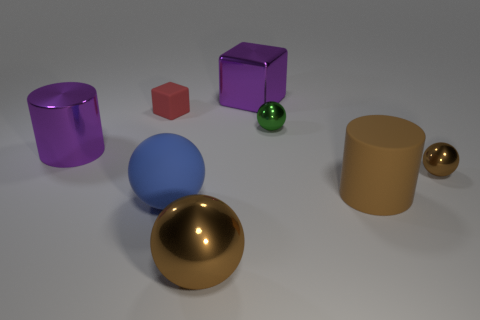What materials do the objects seem to be made out of? The objects have a shiny, reflective quality suggestive of polished metal or perhaps plastic with a metallic finish. The specific material is not certain without further context. Is there a color that is most dominant in this image? While there is no overwhelmingly dominant color, blue is a strong presence because of the large blue sphere centrally located and its vibrant hue. 